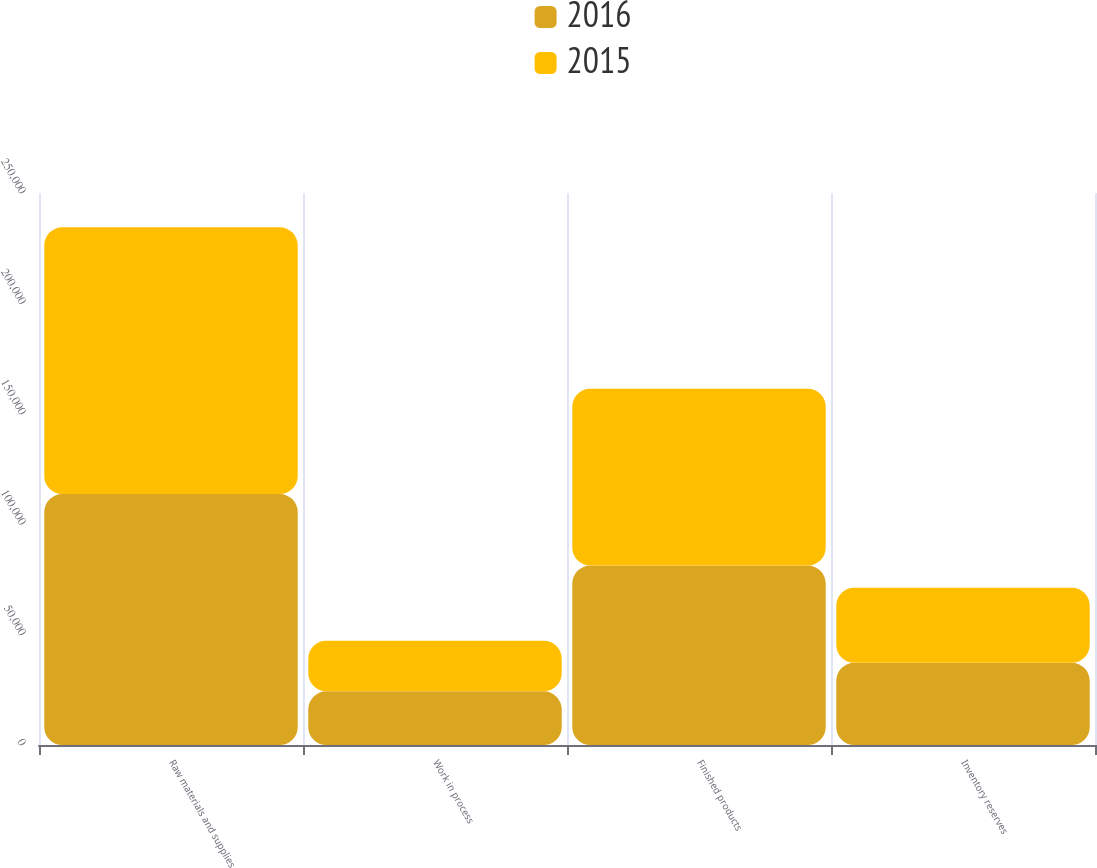Convert chart to OTSL. <chart><loc_0><loc_0><loc_500><loc_500><stacked_bar_chart><ecel><fcel>Raw materials and supplies<fcel>Work in process<fcel>Finished products<fcel>Inventory reserves<nl><fcel>2016<fcel>113632<fcel>24290<fcel>81263<fcel>37233<nl><fcel>2015<fcel>120811<fcel>22979<fcel>80118<fcel>34040<nl></chart> 